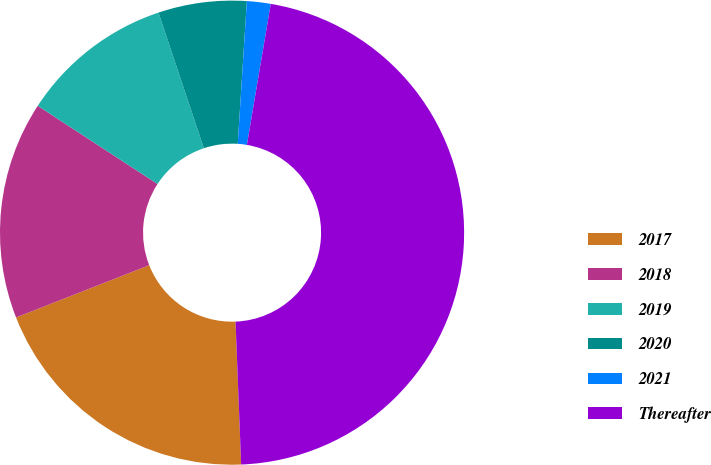<chart> <loc_0><loc_0><loc_500><loc_500><pie_chart><fcel>2017<fcel>2018<fcel>2019<fcel>2020<fcel>2021<fcel>Thereafter<nl><fcel>19.67%<fcel>15.16%<fcel>10.66%<fcel>6.15%<fcel>1.65%<fcel>46.71%<nl></chart> 